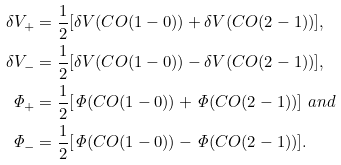<formula> <loc_0><loc_0><loc_500><loc_500>\delta { V _ { + } } & = \frac { 1 } { 2 } [ \delta { V } ( C O ( 1 - 0 ) ) + \delta { V } ( C O ( 2 - 1 ) ) ] , \\ \delta { V _ { - } } & = \frac { 1 } { 2 } [ \delta { V } ( C O ( 1 - 0 ) ) - \delta { V } ( C O ( 2 - 1 ) ) ] , \\ \mathit { \Phi } _ { + } & = \frac { 1 } { 2 } [ \mathit { \Phi } ( C O ( 1 - 0 ) ) + \mathit { \Phi } ( C O ( 2 - 1 ) ) ] \ a n d \\ \mathit { \Phi } _ { - } & = \frac { 1 } { 2 } [ \mathit { \Phi } ( C O ( 1 - 0 ) ) - \mathit { \Phi } ( C O ( 2 - 1 ) ) ] .</formula> 